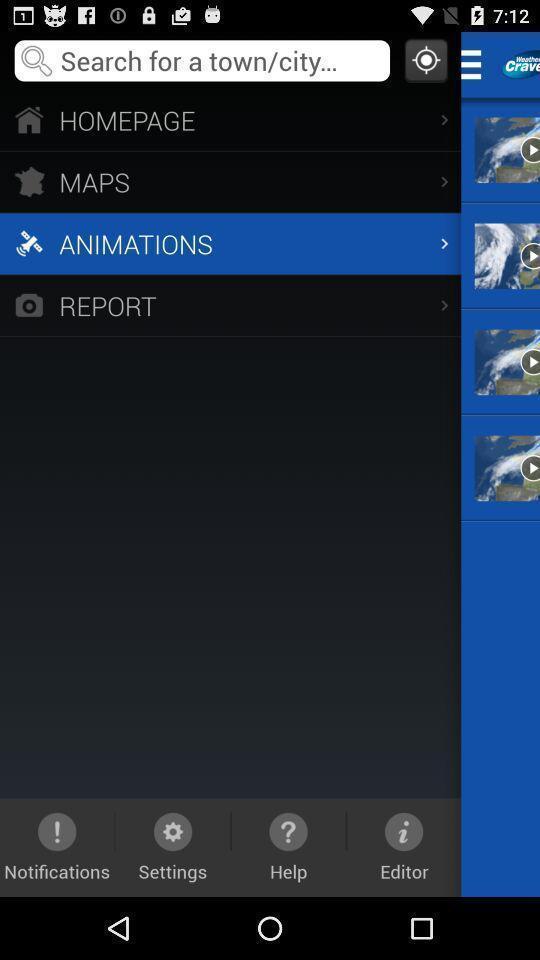Give me a summary of this screen capture. Screen displaying multiple options in a mapping application. 